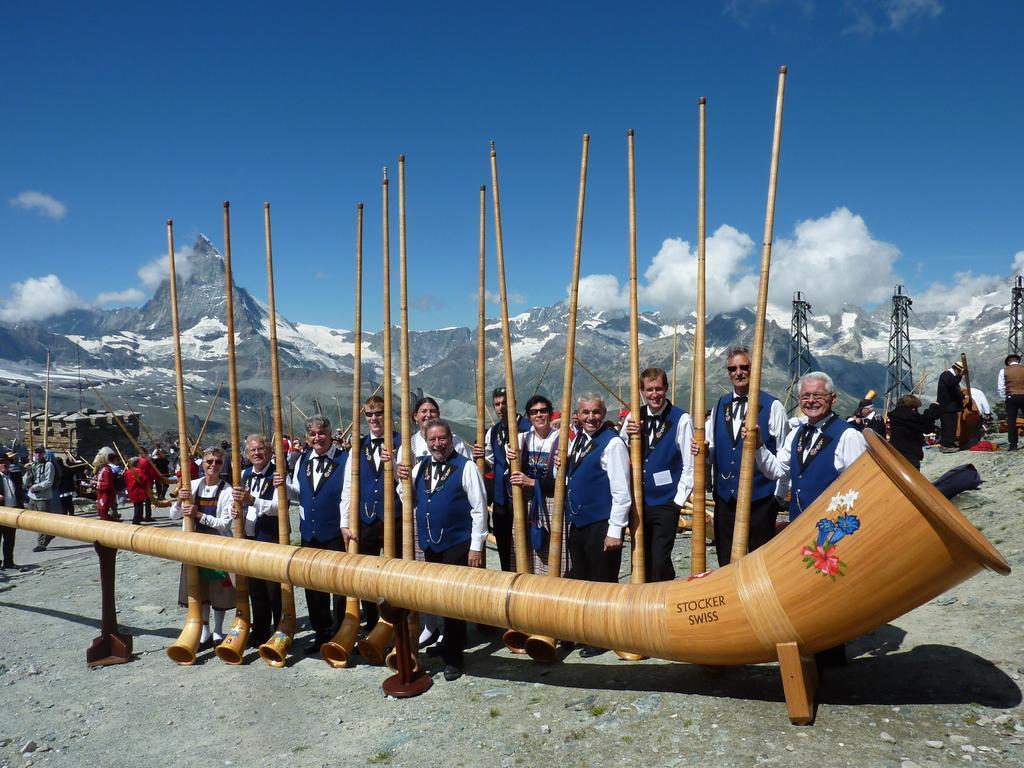Describe this image in one or two sentences. In the image there are few old people in vase coats holding big musical instruments standing in front of a huge wooden pipe and behind them there are hills with snow on it and towers on the left side and above its sky with clouds. 